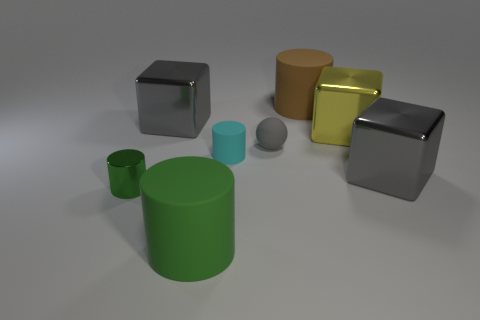Subtract all cyan cylinders. How many cylinders are left? 3 Subtract all small green cylinders. How many cylinders are left? 3 Add 2 rubber balls. How many objects exist? 10 Subtract all red cylinders. Subtract all green blocks. How many cylinders are left? 4 Subtract all balls. How many objects are left? 7 Subtract all tiny blue rubber balls. Subtract all green matte things. How many objects are left? 7 Add 4 green metal things. How many green metal things are left? 5 Add 3 brown matte objects. How many brown matte objects exist? 4 Subtract 1 cyan cylinders. How many objects are left? 7 